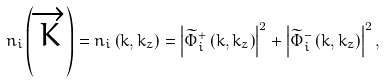Convert formula to latex. <formula><loc_0><loc_0><loc_500><loc_500>n _ { i } \left ( \overrightarrow { K } \right ) = n _ { i } \left ( k , k _ { z } \right ) = \left | \widetilde { \Phi } _ { i } ^ { + } \left ( k , k _ { z } \right ) \right | ^ { 2 } + \left | \widetilde { \Phi } _ { i } ^ { - } \left ( k , k _ { z } \right ) \right | ^ { 2 } ,</formula> 